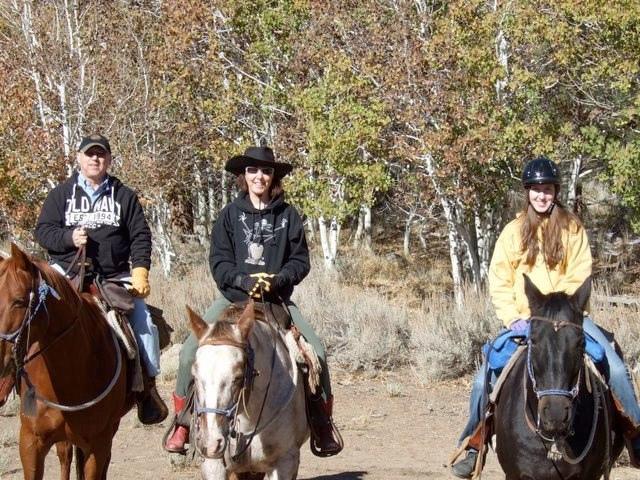How many people are there?
Give a very brief answer. 3. How many horses are in the photo?
Give a very brief answer. 3. 